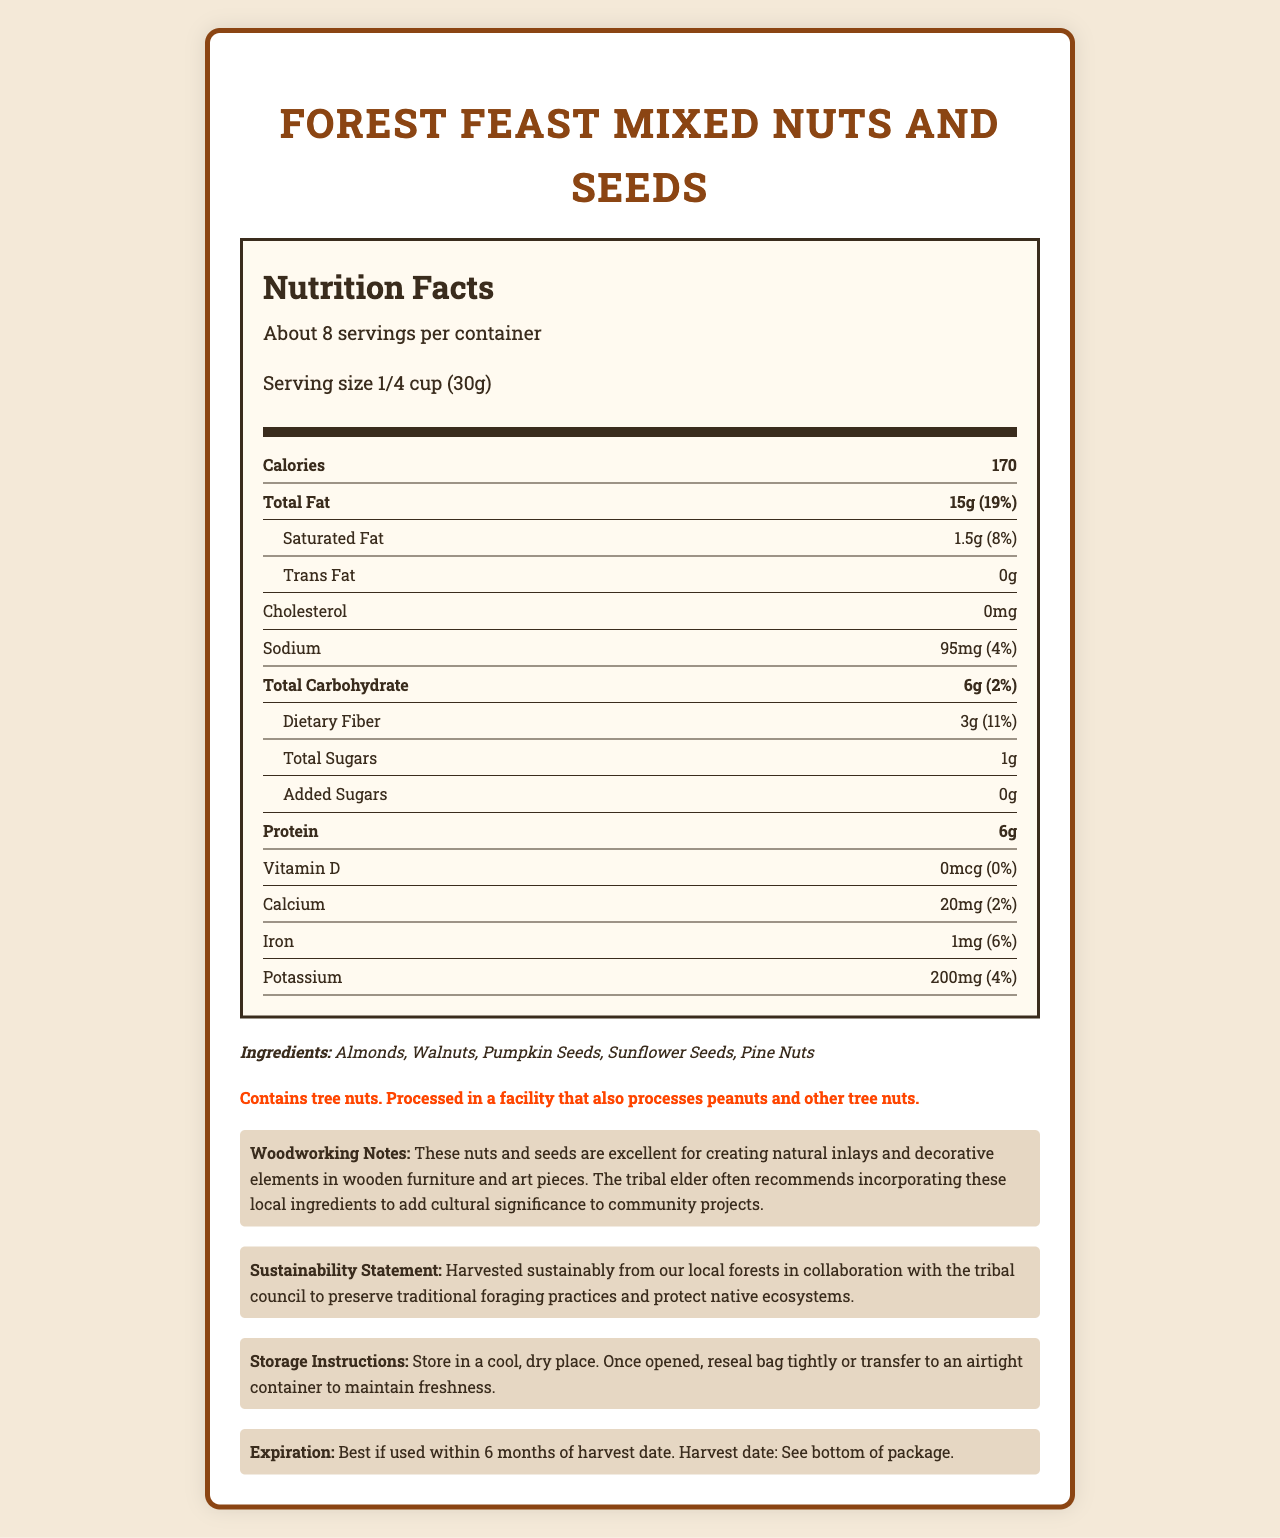What is the serving size of Forest Feast Mixed Nuts and Seeds? The serving size is listed as "1/4 cup (30g)" near the top of the nutrition facts section.
Answer: 1/4 cup (30g) How many servings are in one container of Forest Feast Mixed Nuts and Seeds? The document states there are "About 8" servings per container.
Answer: About 8 What is the total fat content per serving? The total fat content per serving is listed as "15g" in the nutrition facts section.
Answer: 15g How much sodium is in a single serving? The sodium content is listed as "95mg" per serving.
Answer: 95mg What are the ingredients in Forest Feast Mixed Nuts and Seeds? The ingredients list these five items specifically.
Answer: Almonds, Walnuts, Pumpkin Seeds, Sunflower Seeds, Pine Nuts How much daily value of iron does each serving provide? The nutrition facts state that the serving provides 6% of the daily value of iron.
Answer: 6% Is there any cholesterol in a serving of Forest Feast Mixed Nuts and Seeds? The document lists "Cholesterol: 0mg," meaning there is no cholesterol.
Answer: No How many grams of protein are in each serving? The protein content per serving is listed as "6g".
Answer: 6g Which of the following vitamins or minerals is not present in Forest Feast Mixed Nuts and Seeds? A. Vitamin D, B. Calcium, C. Iron, D. Potassium The document shows Vitamin D has an amount of "0mcg" and "0%" daily value, indicating it is not present.
Answer: A Which of these nuts or seeds is an ingredient in Forest Feast Mixed Nuts and Seeds? (Select all that apply) I. Almonds, II. Walnuts, III. Pumpkin Seeds, IV. Cashews The ingredients list includes Almonds, Walnuts, and Pumpkin Seeds but does not mention Cashews.
Answer: I, II, III Is there any information about added sugars in this product? The nutrition facts section notes "Added Sugars: 0g".
Answer: Yes Summarize the main idea of the document. The document contains detailed nutritional information, ingredient list, and special notes related to woodworking and sustainability, intended to inform the user about the contents and benefits of the product.
Answer: The document provides nutrition facts, ingredients, allergen information, and additional notes about Forest Feast Mixed Nuts and Seeds, a sustainably harvested product. What is the sustainable harvesting practice mentioned in the document? The sustainability statement mentions that the nuts and seeds are harvested sustainably from local forests in collaboration with the tribal council to preserve traditional foraging practices and protect native ecosystems.
Answer: It involves collaboration with the tribal council to preserve traditional foraging practices and protect native ecosystems. How should Forest Feast Mixed Nuts and Seeds be stored to maintain freshness? The storage instructions clearly describe the process to maintain freshness.
Answer: Store in a cool, dry place. Once opened, reseal bag tightly or transfer to an airtight container. When is the product best used by? The expiration date states, "Best if used within 6 months of harvest date."
Answer: Within 6 months of the harvest date. What was the harvest date of the product? The document mentions to see the bottom of the package for the harvest date, but it is not explicitly stated in the text provided.
Answer: Cannot be determined 